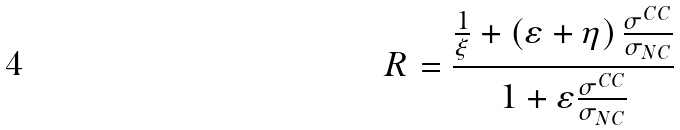Convert formula to latex. <formula><loc_0><loc_0><loc_500><loc_500>R = \frac { \frac { 1 } { \xi } + \left ( \varepsilon + \eta \right ) \frac { \sigma ^ { C C } } { \sigma _ { N C } } } { 1 + \varepsilon \frac { \sigma ^ { C C } } { \sigma _ { N C } } }</formula> 